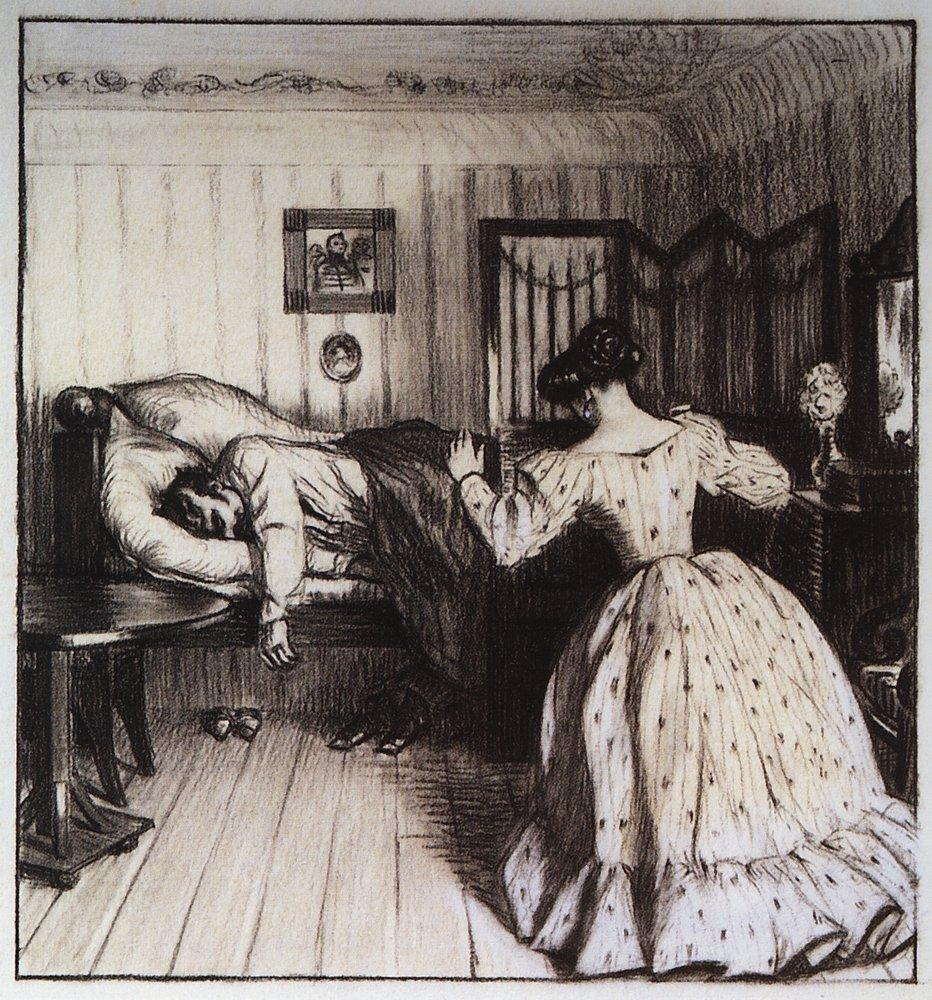What is this photo about? This image is a finely detailed black and white etching that portrays a serene domestic setting, most likely from the late 19th or early 20th century. It features a woman in a voluminous gown absorbed in reading a book, embodying a moment of peaceful contemplation or leisure. Opposite her, a man seems to be resting deeply on a couch, possibly symbolizing rest or the contrasting roles within the household. The setting is enriched with elements of decor such as a tapestried wall, a table adorned with a vase of flowers, and art on the walls, suggesting a well-furnished middle-class home. The artwork subtly invites viewers to ponder domestic life and gender roles in historical contexts, offering a glimpse into the everyday yet profound moments of past eras. 